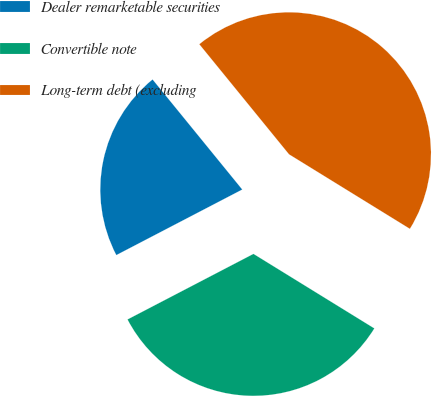Convert chart. <chart><loc_0><loc_0><loc_500><loc_500><pie_chart><fcel>Dealer remarketable securities<fcel>Convertible note<fcel>Long-term debt (excluding<nl><fcel>21.76%<fcel>33.57%<fcel>44.68%<nl></chart> 